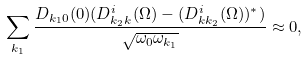Convert formula to latex. <formula><loc_0><loc_0><loc_500><loc_500>\sum _ { { k } _ { 1 } } \frac { D _ { { k } _ { 1 } 0 } ( 0 ) ( D _ { { k } _ { 2 } { k } } ^ { i } ( \Omega ) - ( D _ { { k } { k } _ { 2 } } ^ { i } ( \Omega ) ) ^ { * } ) } { \sqrt { \omega _ { 0 } \omega _ { { k } _ { 1 } } } } \approx 0 ,</formula> 